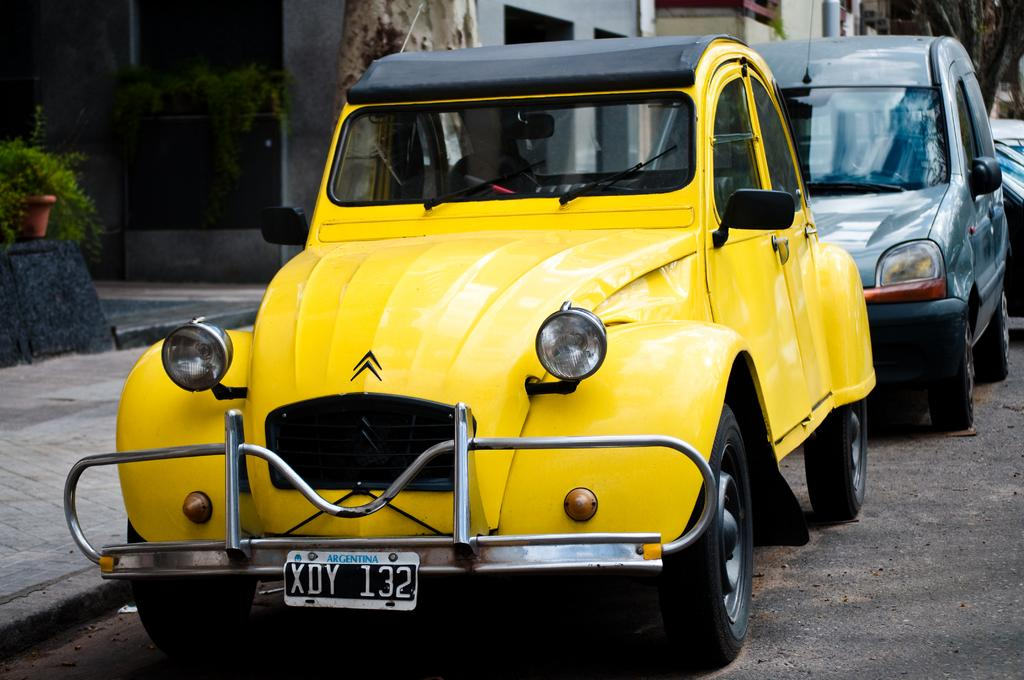<image>
Render a clear and concise summary of the photo. The yellow car with a black top has the licence plate of XDY 132. 